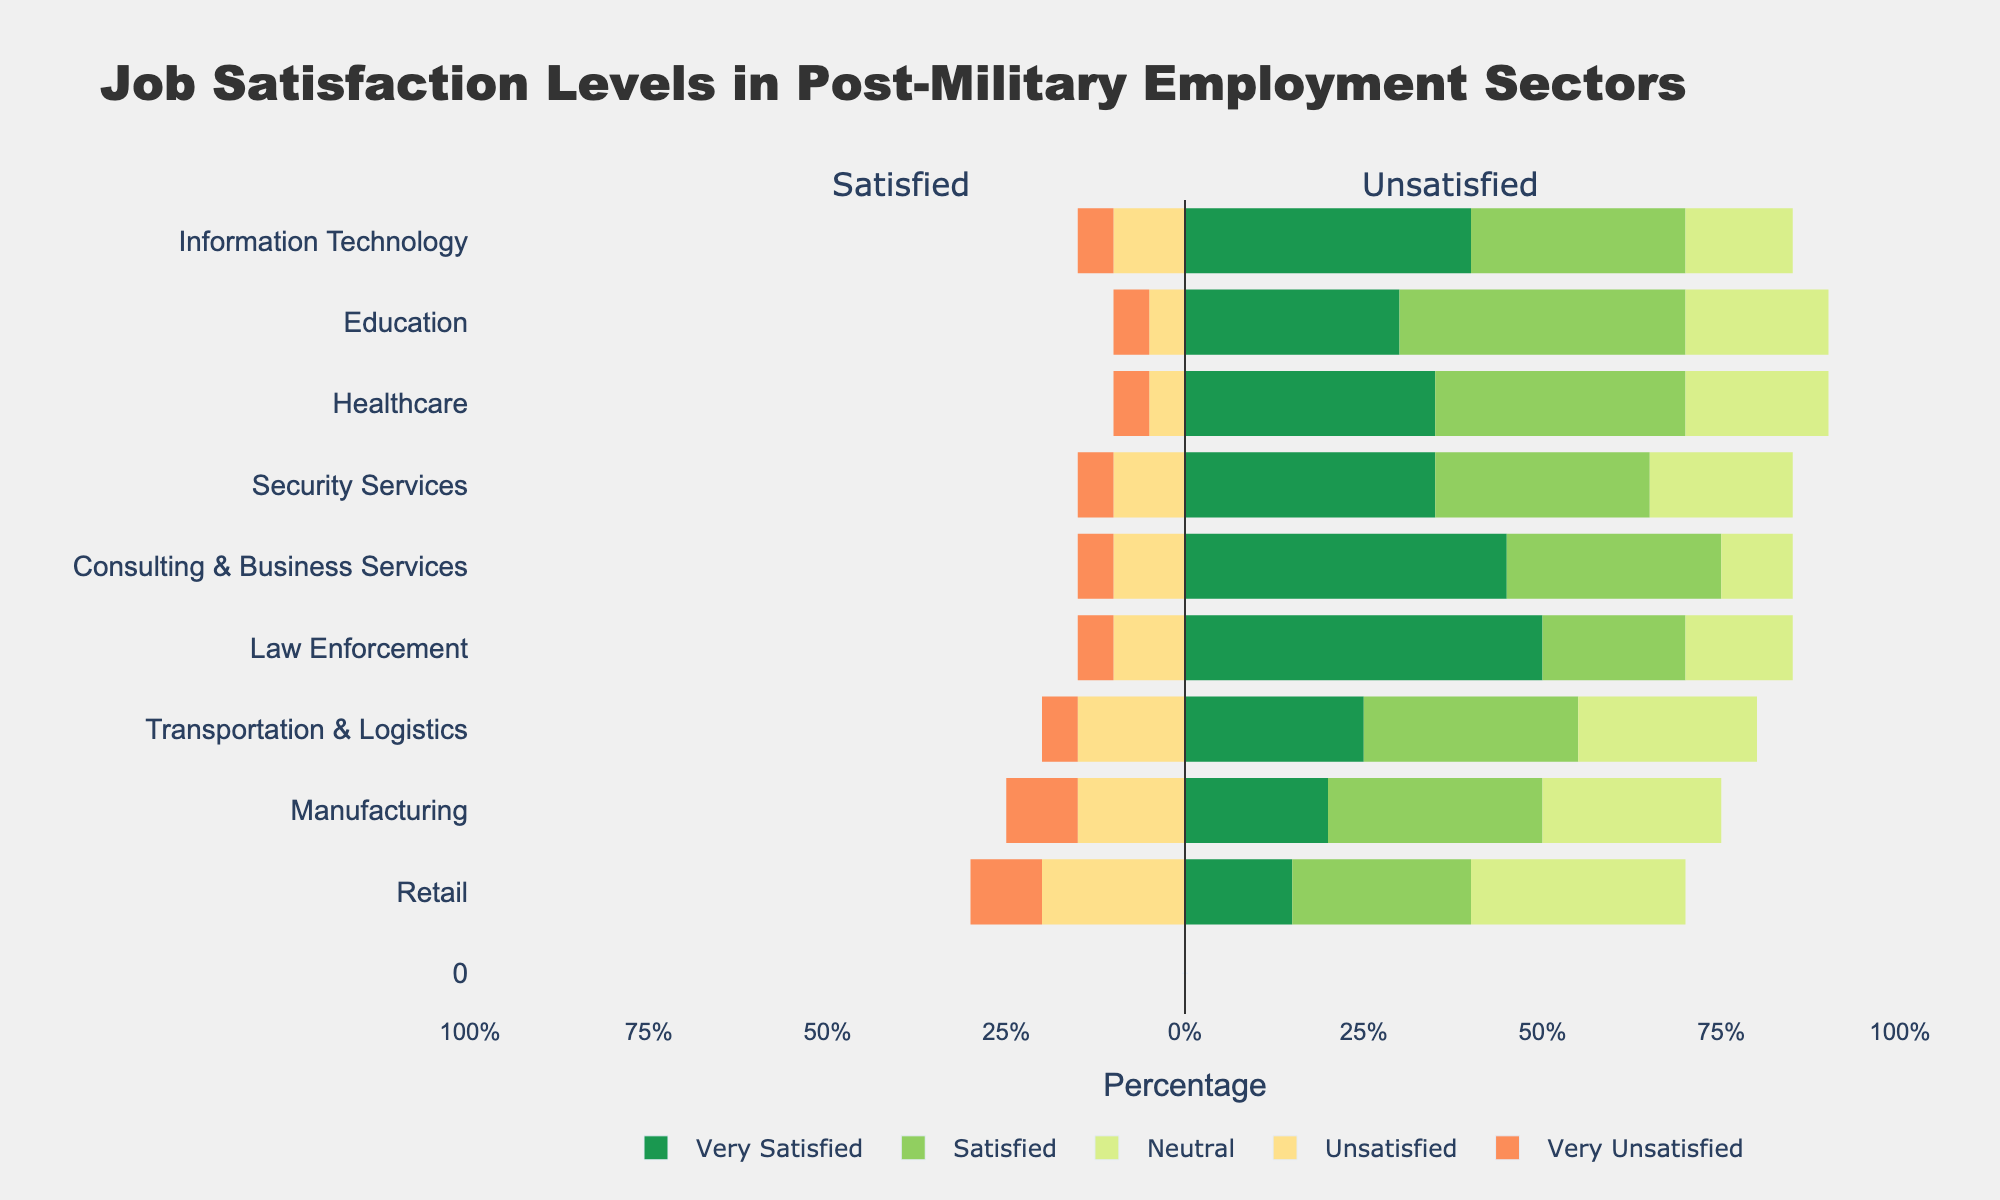Which employment sector has the highest percentage of "Very Satisfied" retired military personnel? The bar for "Law Enforcement" extends the furthest in the positive direction, indicating it has the highest percentage of "Very Satisfied" respondents.
Answer: Law Enforcement Which sector has the highest combined percentage of "Very Satisfied" and "Satisfied" respondents? By visually summing the lengths of the "Very Satisfied" and "Satisfied" bars for each sector, "Consulting & Business Services" has the biggest combined length.
Answer: Consulting & Business Services Compare the percentages of "Unsatisfied" and "Very Unsatisfied" in the Manufacturing sector. Which is higher? In the Manufacturing sector, both "Unsatisfied" and "Very Unsatisfied" extend to the left. "Unsatisfied" has a larger horizontal bar compared to "Very Unsatisfied."
Answer: Unsatisfied Which employment sector has the highest percentage of "Neutral" respondents? The longest "Neutral" bar is seen in the "Retail" sector, indicating the highest percentage.
Answer: Retail For the Information Technology sector, what is the combined percentage of "Unsatisfied" and "Very Unsatisfied" respondents? Add the lengths of the "Unsatisfied" and "Very Unsatisfied" bars for the Information Technology sector. You get 10% + 5% = 15%.
Answer: 15% Between the Healthcare and Education sectors, which has a higher percentage of "Very Satisfied" respondents? By comparing the lengths of the "Very Satisfied" bars, Healthcare has a longer bar than Education.
Answer: Healthcare Which sector shows the smallest percentage difference between "Satisfied" and "Unsatisfied" respondents? Calculating the difference between "Satisfied" and "Unsatisfied" bars for each sector, the sector with the smallest difference is "Healthcare."
Answer: Healthcare In the Security Services sector, what is the ratio of "Very Satisfied" to "Unsatisfied" respondents? The "Very Satisfied" bar is 35% and the "Unsatisfied" bar is 10%. The ratio is 35:10 or simplified to 7:2.
Answer: 7:2 Which sector has a more balanced distribution of job satisfaction levels? Observing the sector bars across all job satisfaction categories, "Transportation & Logistics" shows the most balanced lengths.
Answer: Transportation & Logistics 